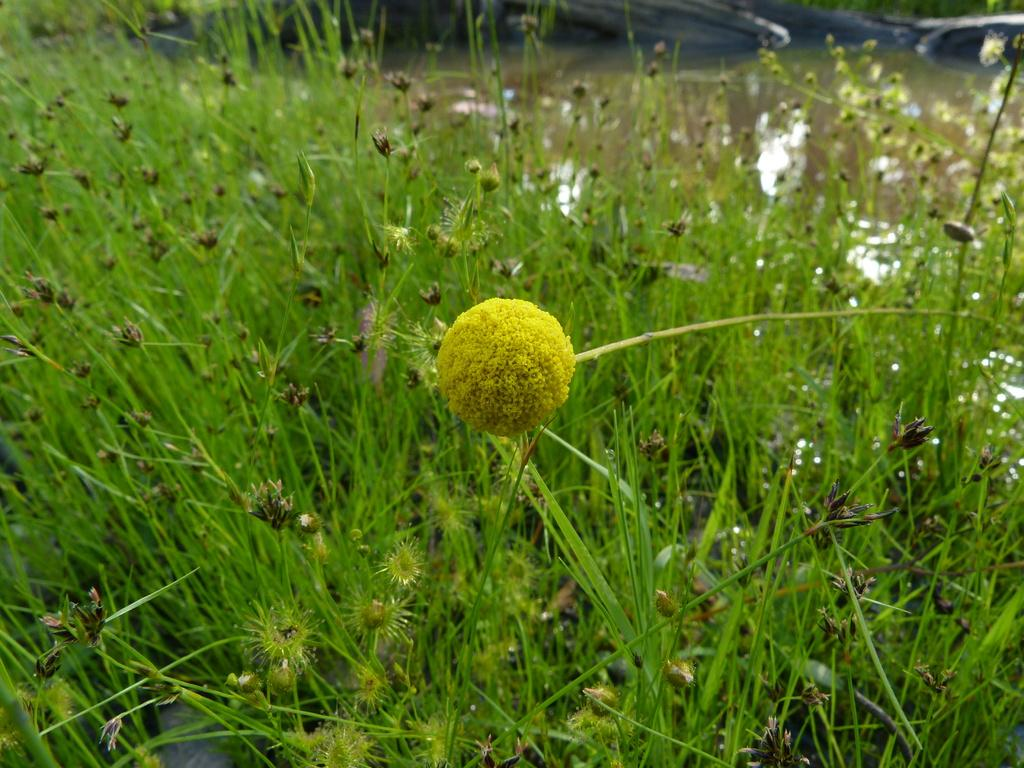What is the main subject of the image? There is a yellow flower in the center of the image. What else can be seen in the image besides the yellow flower? There are plants around the area of the image. Where is the tub located in the image? There is no tub present in the image. What things can be seen in the image besides the yellow flower and plants? The image only shows a yellow flower and plants, so there are no other things visible. 